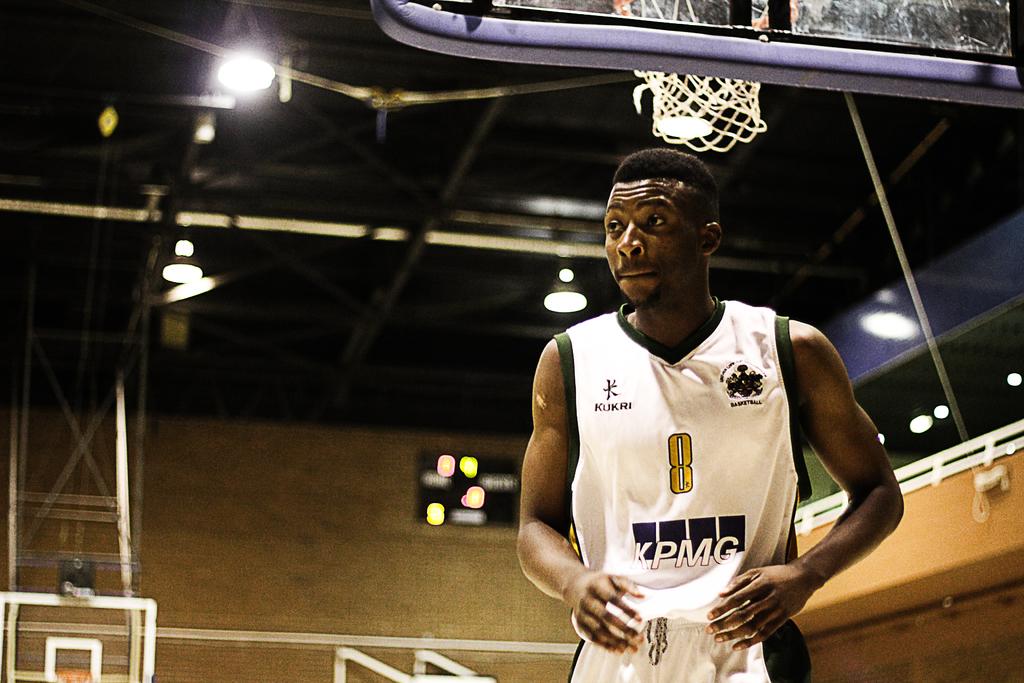What is the player's number?
Your response must be concise. 8. Which accounting firm is sponsoring this team?
Make the answer very short. Kpmg. 